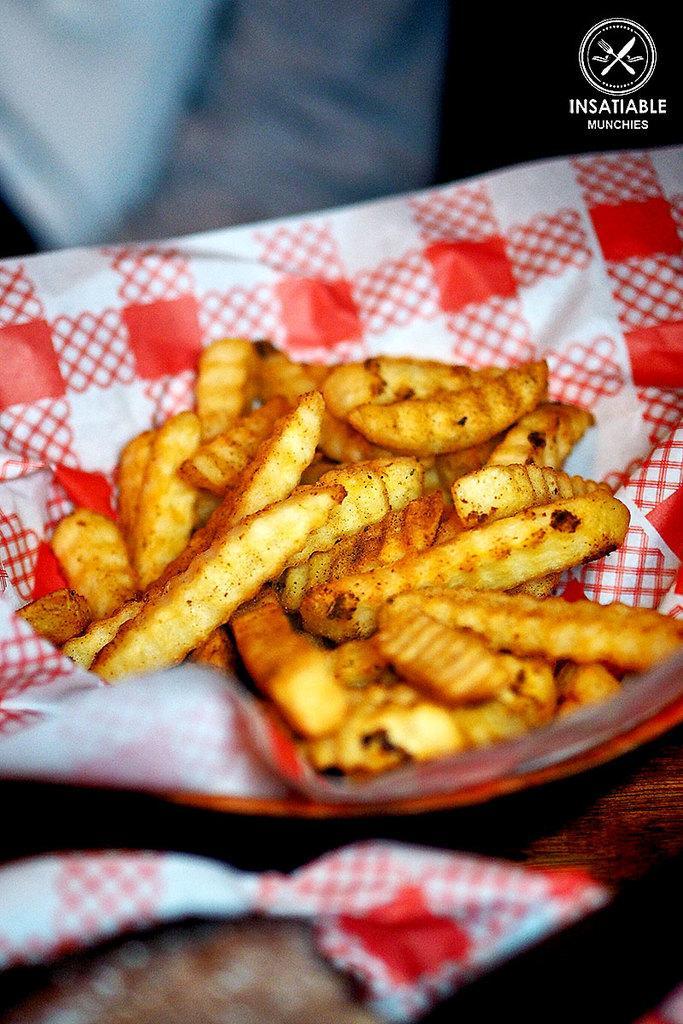How would you summarize this image in a sentence or two? In this image we can see some fries which are in plate and there is a paper in between fries and plate which is in color white and red. 